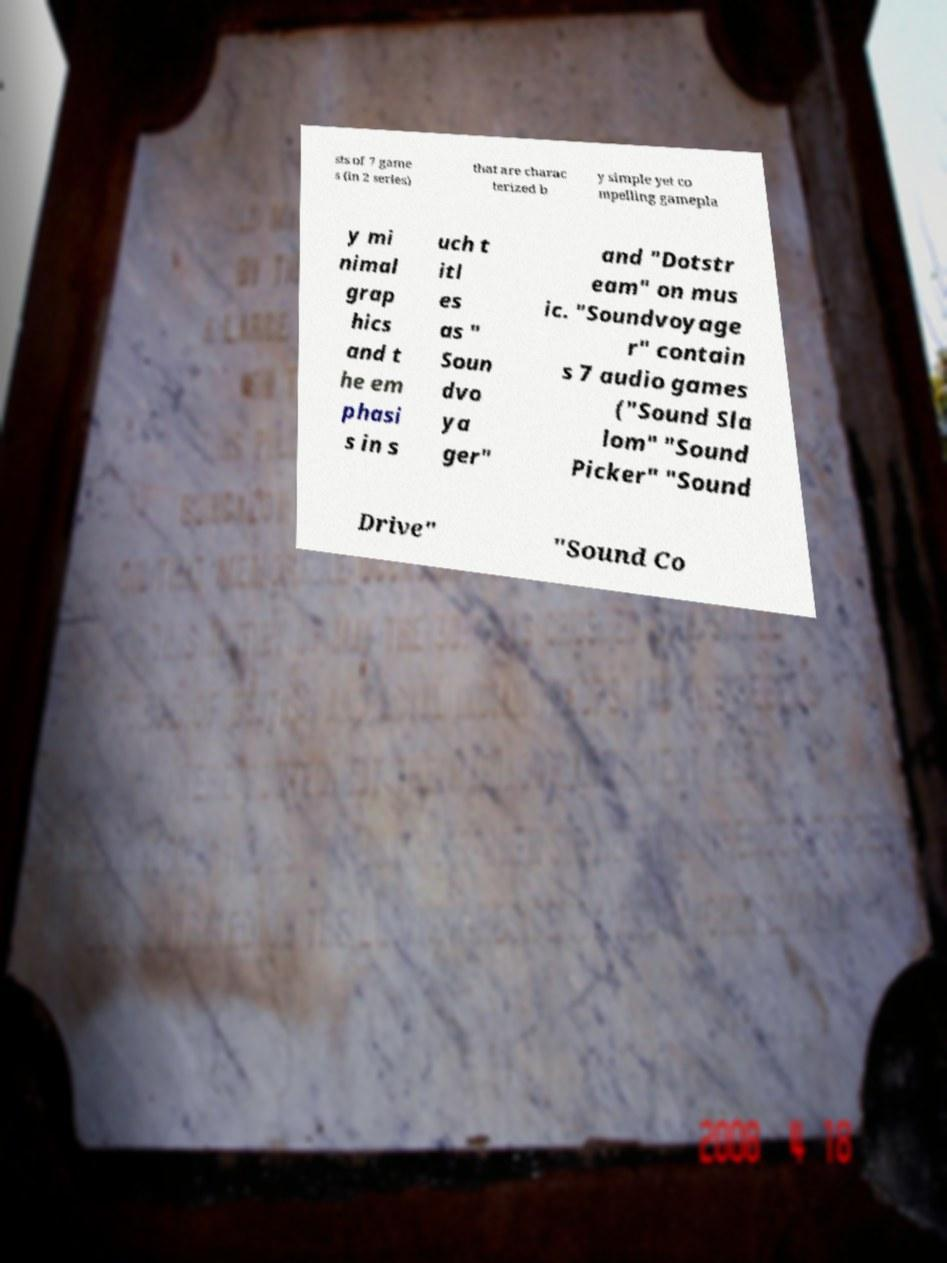There's text embedded in this image that I need extracted. Can you transcribe it verbatim? sts of 7 game s (in 2 series) that are charac terized b y simple yet co mpelling gamepla y mi nimal grap hics and t he em phasi s in s uch t itl es as " Soun dvo ya ger" and "Dotstr eam" on mus ic. "Soundvoyage r" contain s 7 audio games ("Sound Sla lom" "Sound Picker" "Sound Drive" "Sound Co 